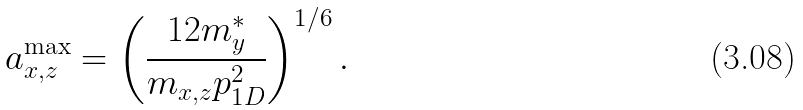Convert formula to latex. <formula><loc_0><loc_0><loc_500><loc_500>a ^ { \max } _ { x , z } = \left ( \frac { 1 2 m ^ { * } _ { y } } { m _ { x , z } p ^ { 2 } _ { 1 D } } \right ) ^ { 1 / 6 } .</formula> 